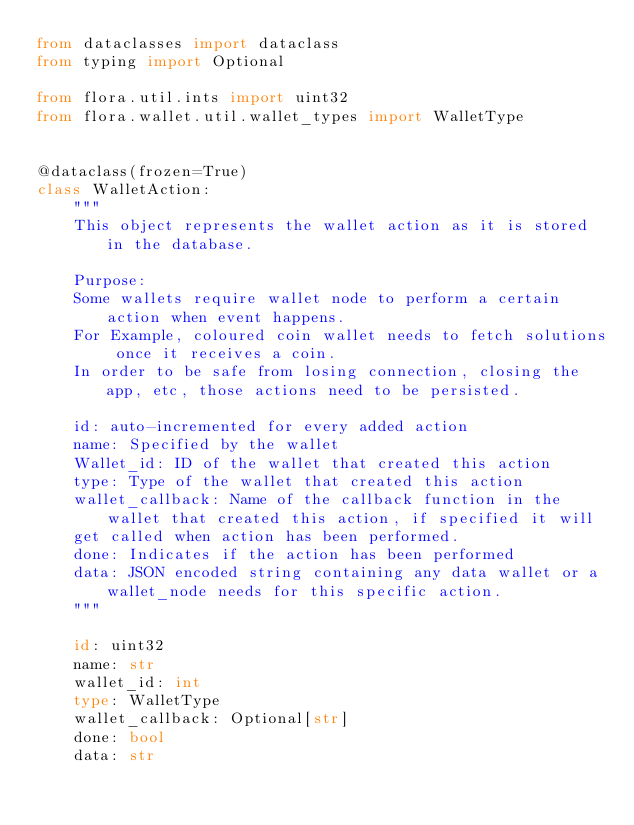<code> <loc_0><loc_0><loc_500><loc_500><_Python_>from dataclasses import dataclass
from typing import Optional

from flora.util.ints import uint32
from flora.wallet.util.wallet_types import WalletType


@dataclass(frozen=True)
class WalletAction:
    """
    This object represents the wallet action as it is stored in the database.

    Purpose:
    Some wallets require wallet node to perform a certain action when event happens.
    For Example, coloured coin wallet needs to fetch solutions once it receives a coin.
    In order to be safe from losing connection, closing the app, etc, those actions need to be persisted.

    id: auto-incremented for every added action
    name: Specified by the wallet
    Wallet_id: ID of the wallet that created this action
    type: Type of the wallet that created this action
    wallet_callback: Name of the callback function in the wallet that created this action, if specified it will
    get called when action has been performed.
    done: Indicates if the action has been performed
    data: JSON encoded string containing any data wallet or a wallet_node needs for this specific action.
    """

    id: uint32
    name: str
    wallet_id: int
    type: WalletType
    wallet_callback: Optional[str]
    done: bool
    data: str
</code> 